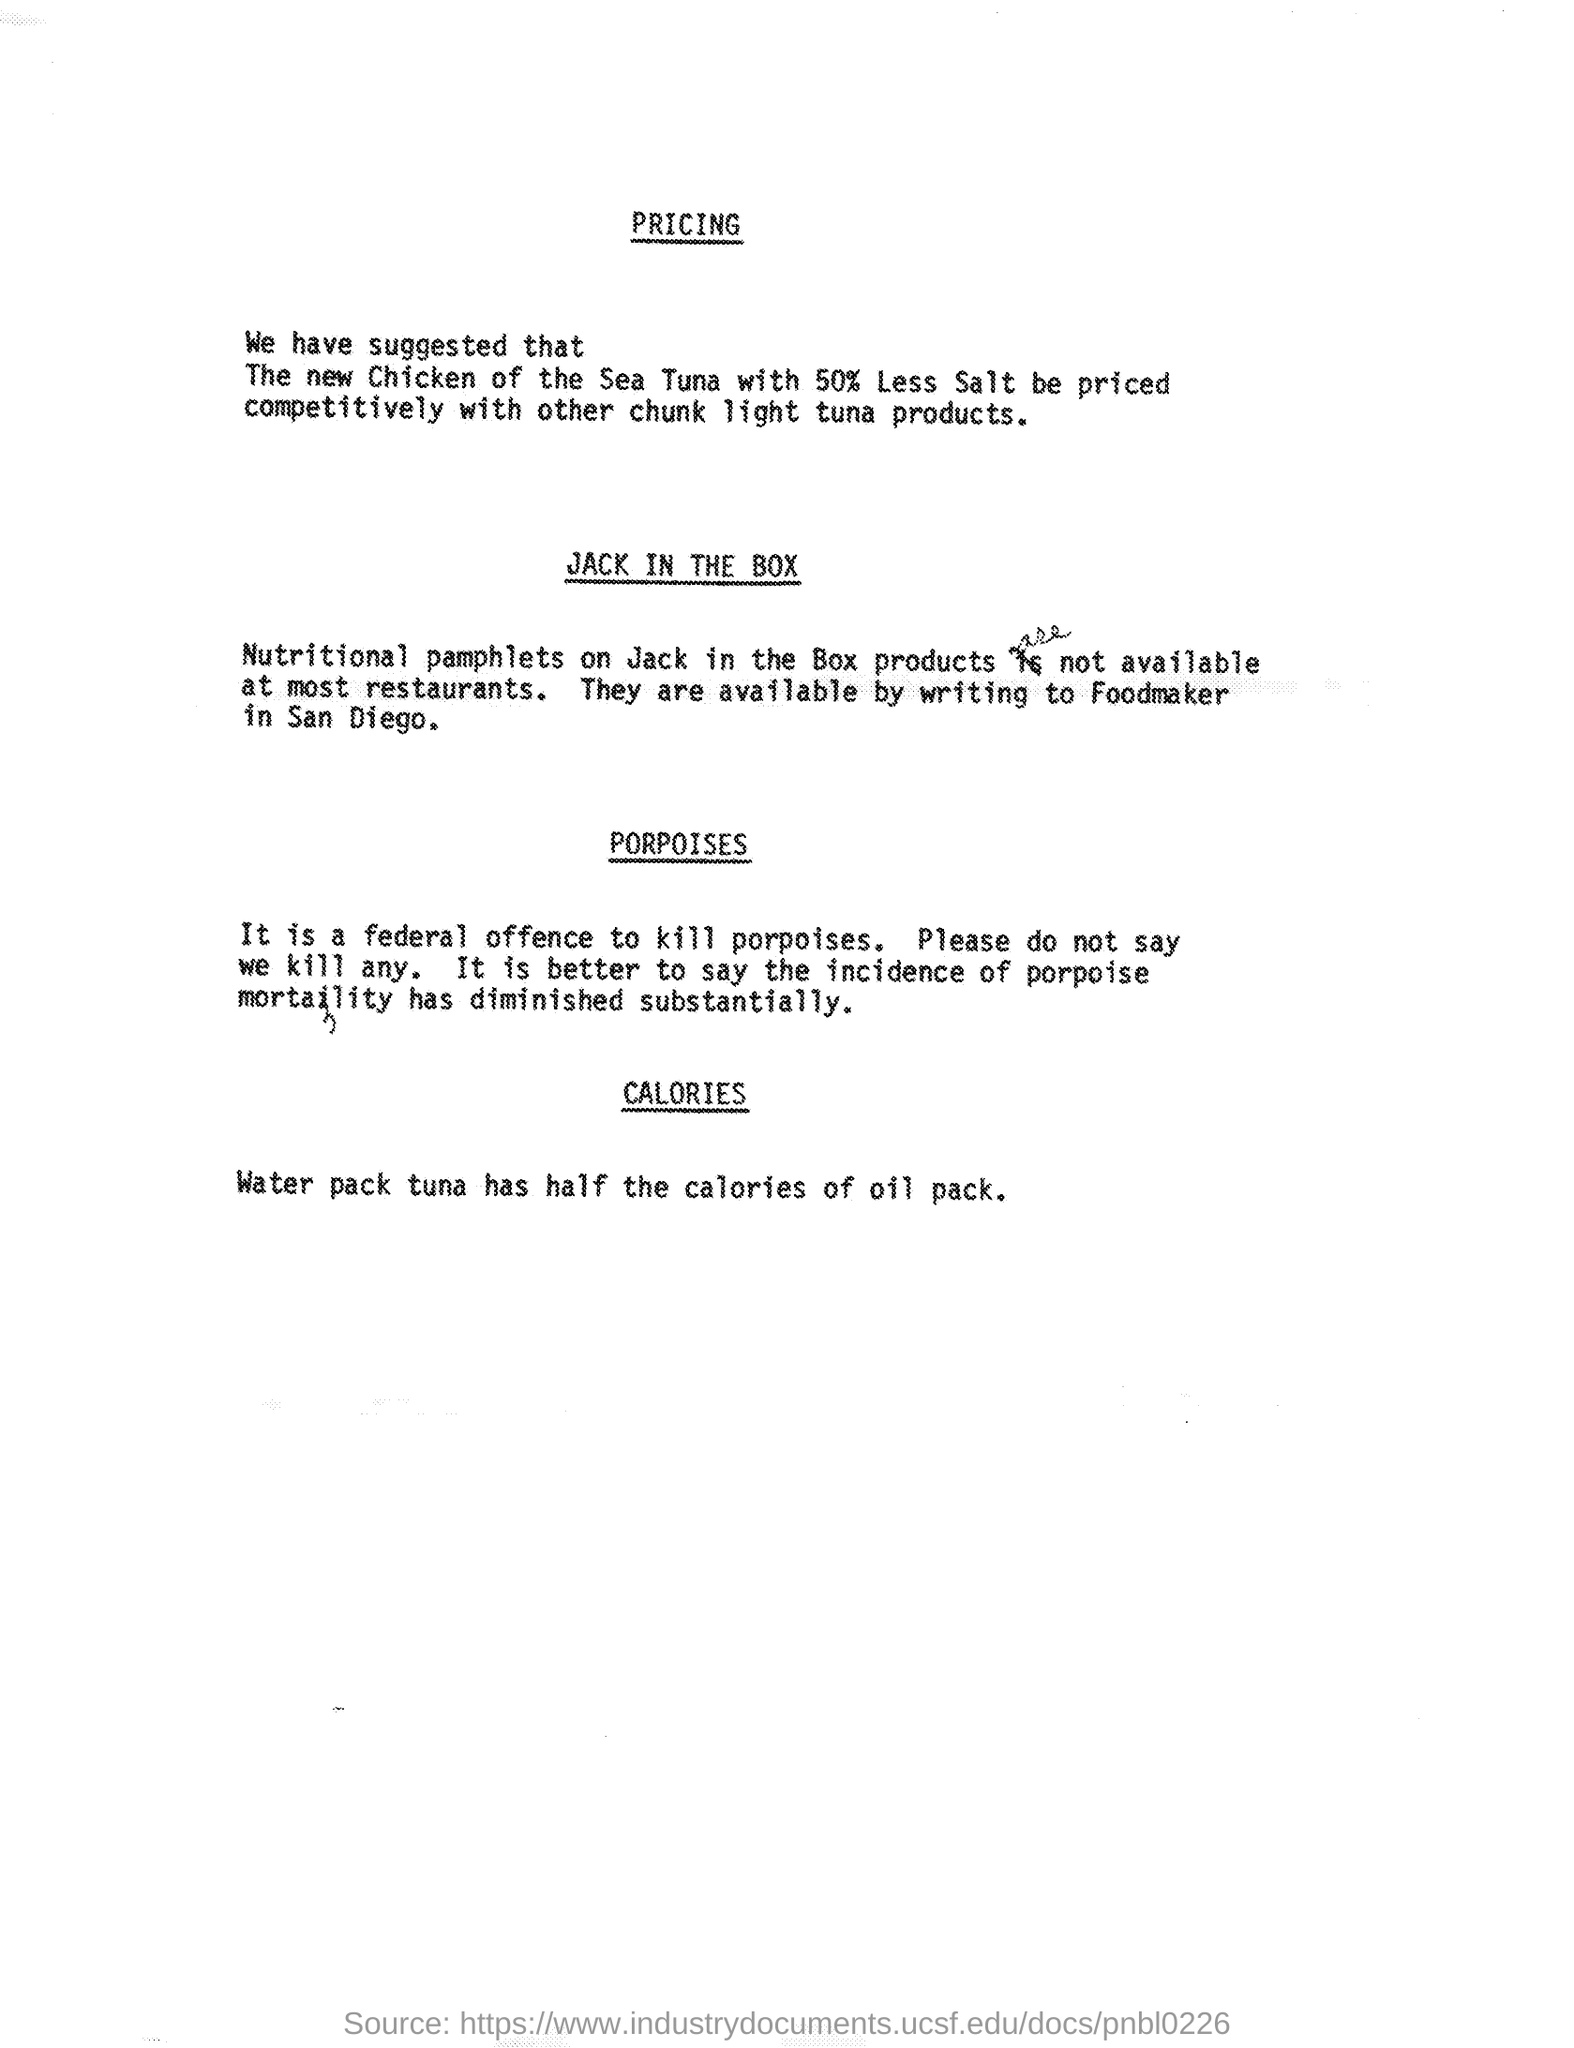What is offence when you kill porpoises?
Keep it short and to the point. Federal offence. 